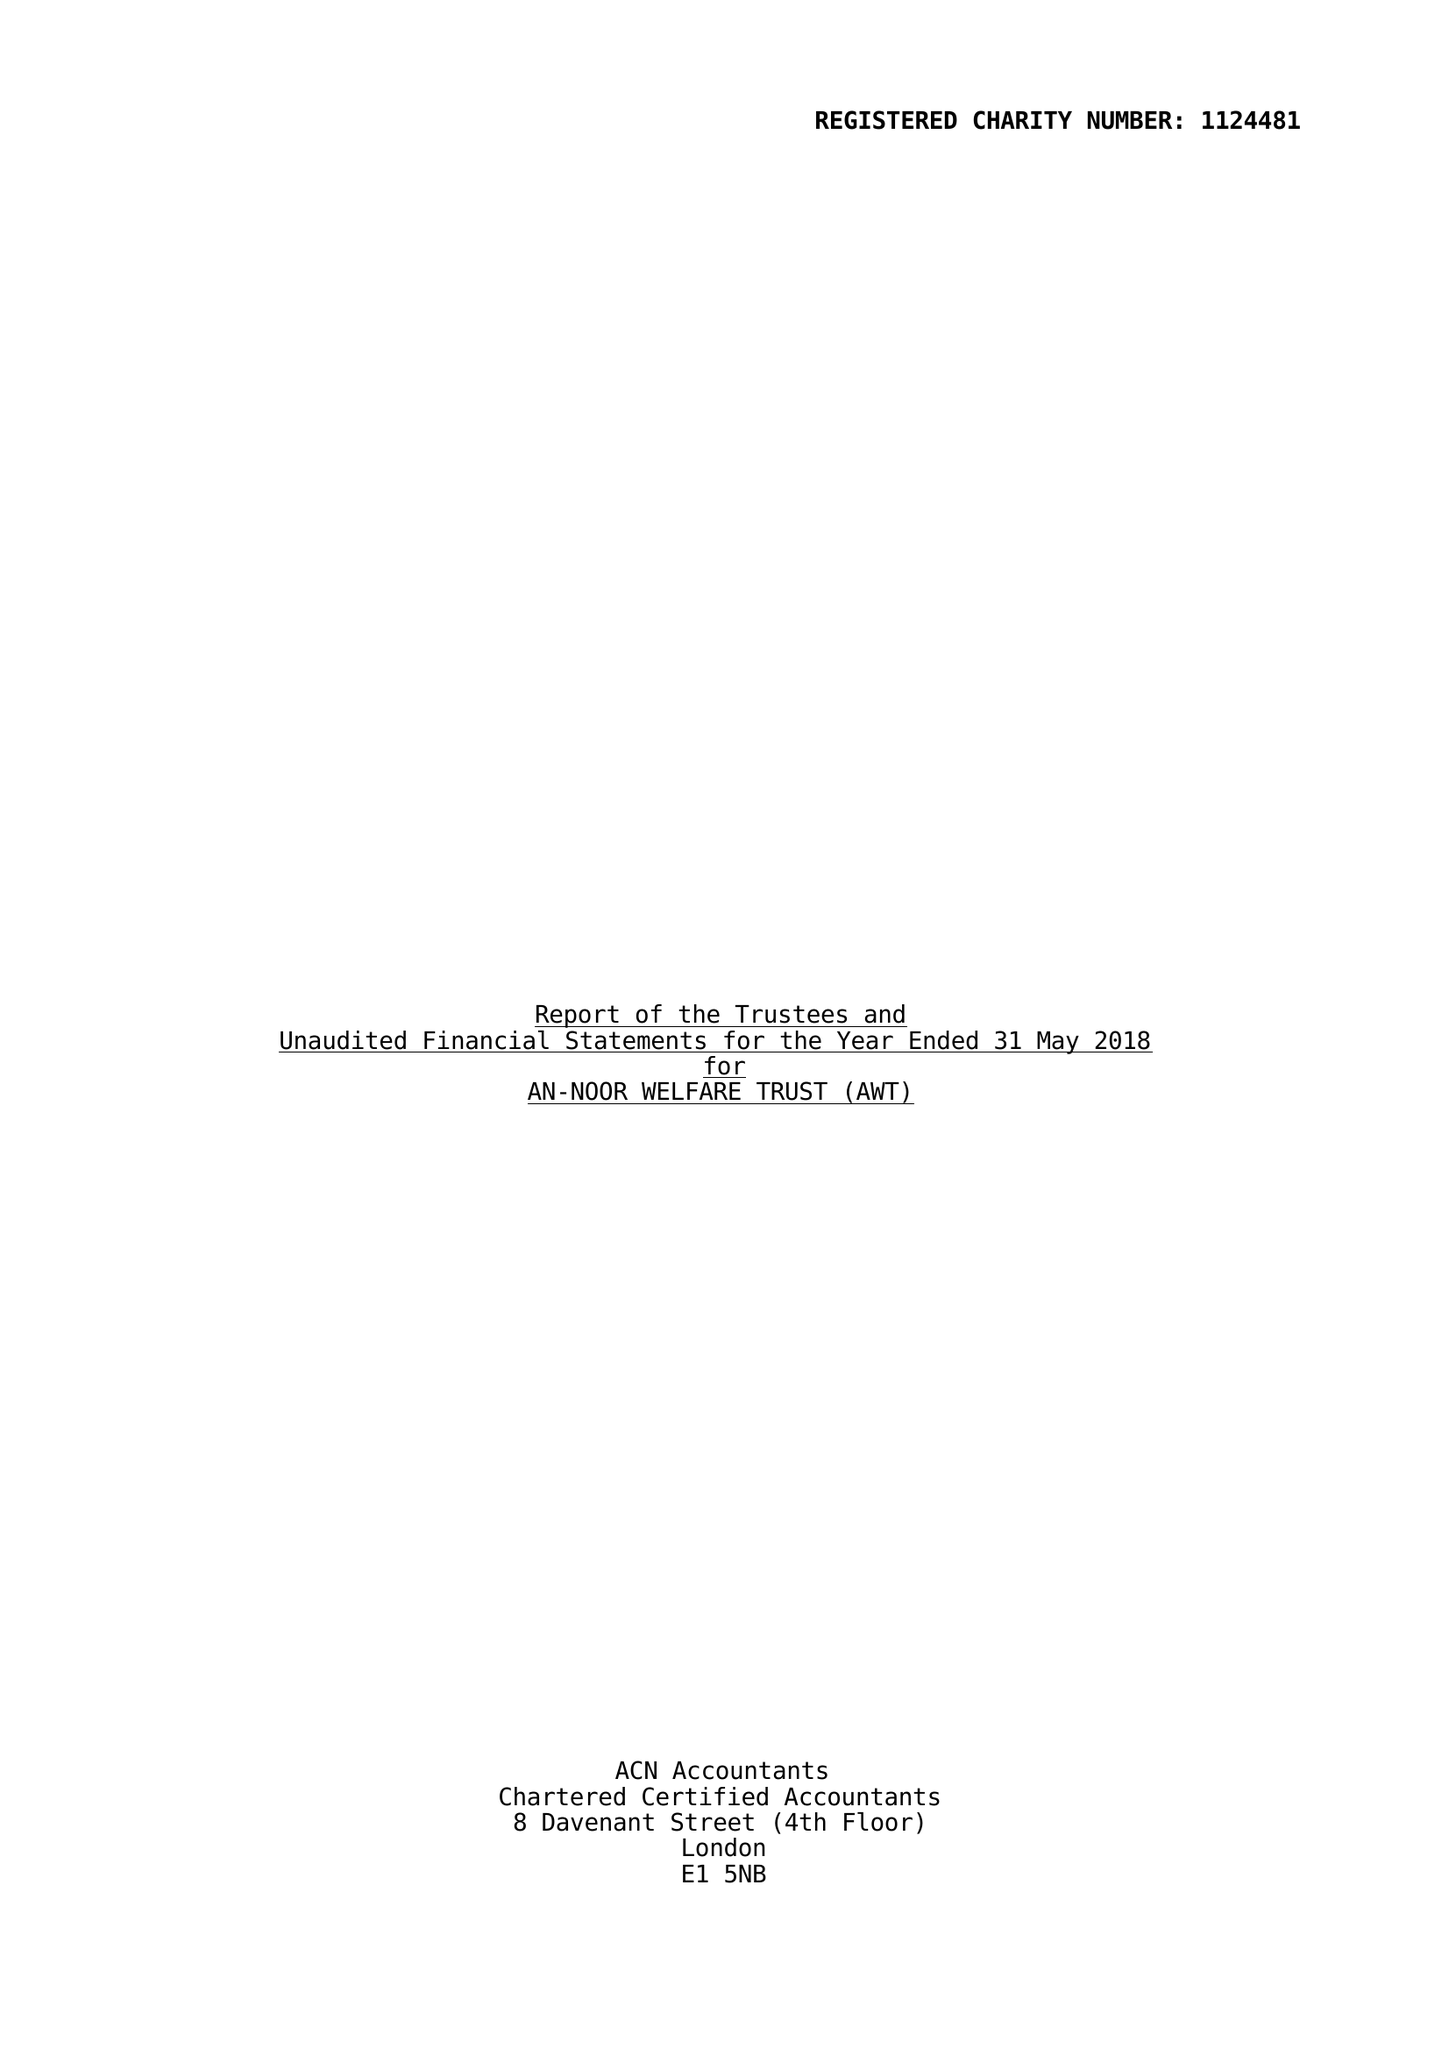What is the value for the spending_annually_in_british_pounds?
Answer the question using a single word or phrase. 48179.00 